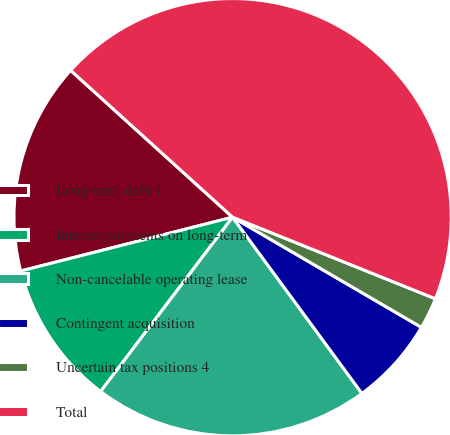Convert chart. <chart><loc_0><loc_0><loc_500><loc_500><pie_chart><fcel>Long-term debt 1<fcel>Interest payments on long-term<fcel>Non-cancelable operating lease<fcel>Contingent acquisition<fcel>Uncertain tax positions 4<fcel>Total<nl><fcel>15.68%<fcel>10.73%<fcel>20.39%<fcel>6.52%<fcel>2.32%<fcel>44.37%<nl></chart> 